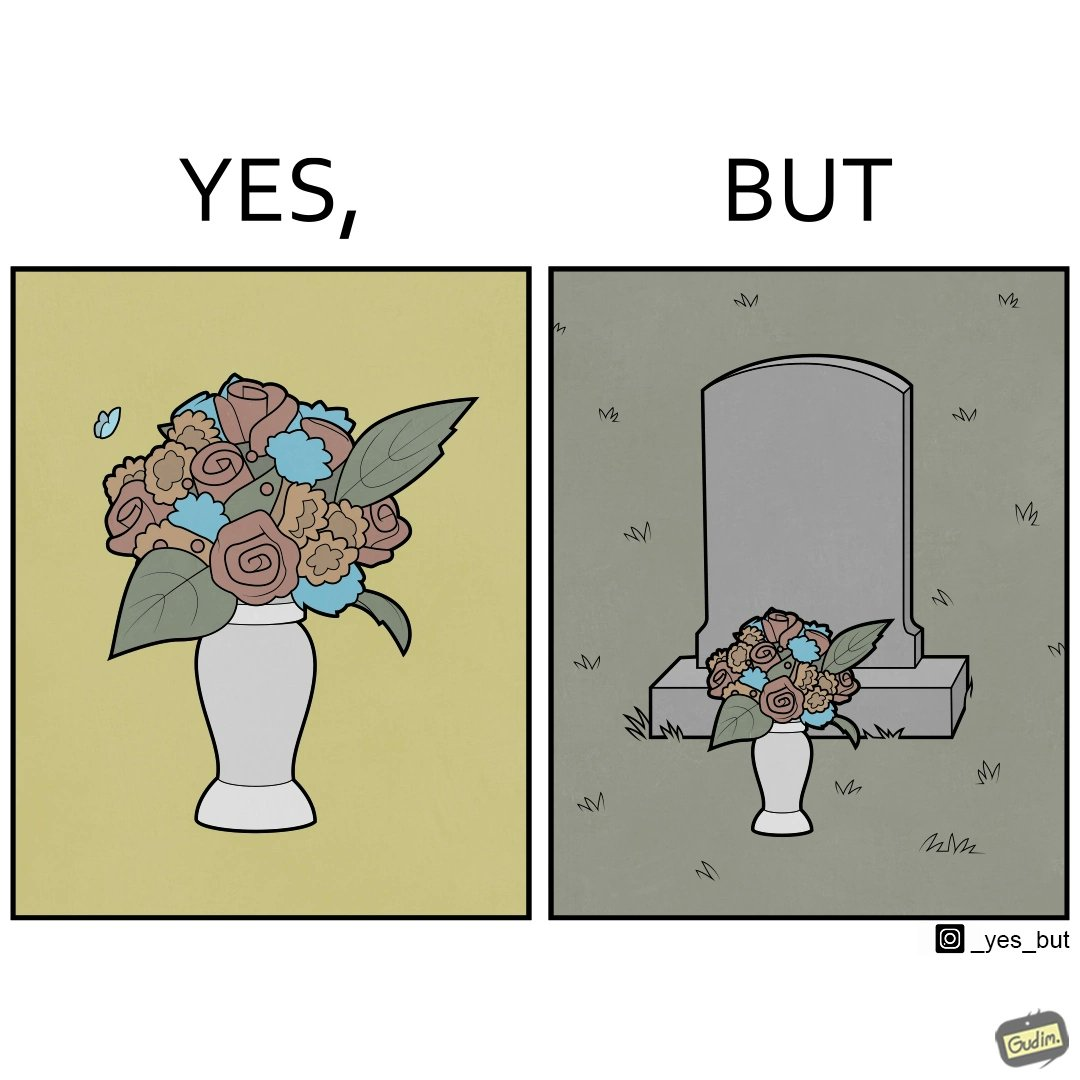Is this a satirical image? Yes, this image is satirical. 